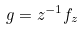<formula> <loc_0><loc_0><loc_500><loc_500>g = z ^ { - 1 } f _ { z }</formula> 